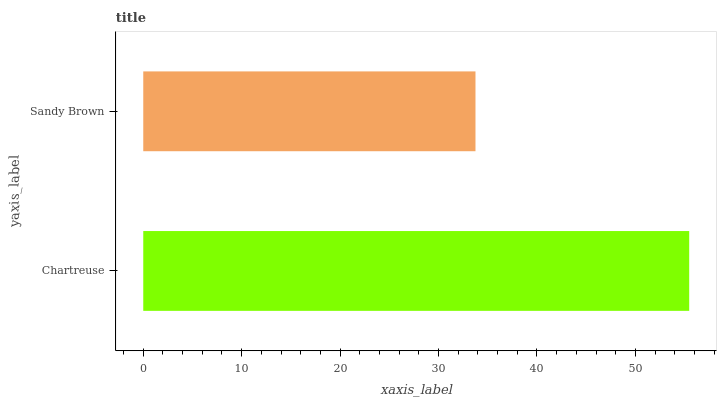Is Sandy Brown the minimum?
Answer yes or no. Yes. Is Chartreuse the maximum?
Answer yes or no. Yes. Is Sandy Brown the maximum?
Answer yes or no. No. Is Chartreuse greater than Sandy Brown?
Answer yes or no. Yes. Is Sandy Brown less than Chartreuse?
Answer yes or no. Yes. Is Sandy Brown greater than Chartreuse?
Answer yes or no. No. Is Chartreuse less than Sandy Brown?
Answer yes or no. No. Is Chartreuse the high median?
Answer yes or no. Yes. Is Sandy Brown the low median?
Answer yes or no. Yes. Is Sandy Brown the high median?
Answer yes or no. No. Is Chartreuse the low median?
Answer yes or no. No. 